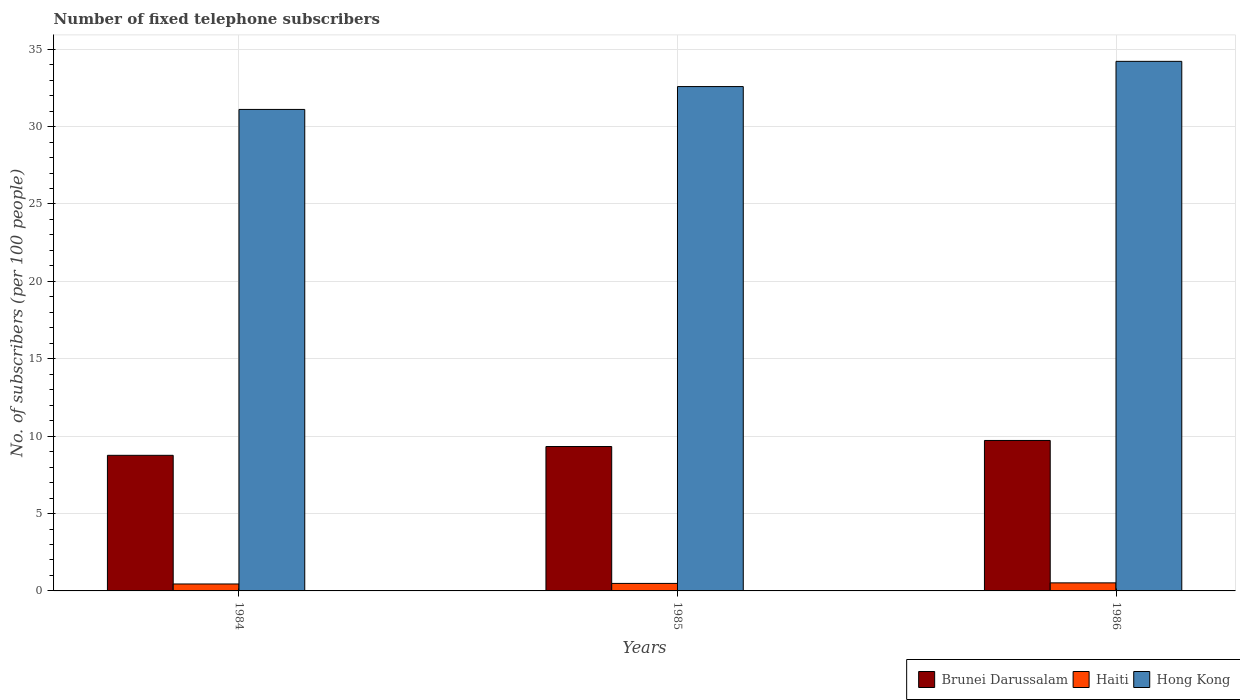How many different coloured bars are there?
Keep it short and to the point. 3. How many groups of bars are there?
Keep it short and to the point. 3. Are the number of bars per tick equal to the number of legend labels?
Provide a succinct answer. Yes. How many bars are there on the 1st tick from the left?
Offer a terse response. 3. How many bars are there on the 2nd tick from the right?
Your answer should be very brief. 3. What is the label of the 1st group of bars from the left?
Provide a short and direct response. 1984. In how many cases, is the number of bars for a given year not equal to the number of legend labels?
Give a very brief answer. 0. What is the number of fixed telephone subscribers in Haiti in 1986?
Provide a succinct answer. 0.52. Across all years, what is the maximum number of fixed telephone subscribers in Haiti?
Provide a short and direct response. 0.52. Across all years, what is the minimum number of fixed telephone subscribers in Haiti?
Your response must be concise. 0.45. What is the total number of fixed telephone subscribers in Brunei Darussalam in the graph?
Give a very brief answer. 27.81. What is the difference between the number of fixed telephone subscribers in Haiti in 1984 and that in 1985?
Ensure brevity in your answer.  -0.04. What is the difference between the number of fixed telephone subscribers in Haiti in 1986 and the number of fixed telephone subscribers in Brunei Darussalam in 1984?
Offer a terse response. -8.24. What is the average number of fixed telephone subscribers in Haiti per year?
Keep it short and to the point. 0.48. In the year 1986, what is the difference between the number of fixed telephone subscribers in Brunei Darussalam and number of fixed telephone subscribers in Hong Kong?
Give a very brief answer. -24.49. What is the ratio of the number of fixed telephone subscribers in Haiti in 1984 to that in 1986?
Provide a succinct answer. 0.86. Is the number of fixed telephone subscribers in Hong Kong in 1984 less than that in 1986?
Ensure brevity in your answer.  Yes. Is the difference between the number of fixed telephone subscribers in Brunei Darussalam in 1984 and 1986 greater than the difference between the number of fixed telephone subscribers in Hong Kong in 1984 and 1986?
Your response must be concise. Yes. What is the difference between the highest and the second highest number of fixed telephone subscribers in Brunei Darussalam?
Ensure brevity in your answer.  0.39. What is the difference between the highest and the lowest number of fixed telephone subscribers in Hong Kong?
Ensure brevity in your answer.  3.11. In how many years, is the number of fixed telephone subscribers in Brunei Darussalam greater than the average number of fixed telephone subscribers in Brunei Darussalam taken over all years?
Offer a very short reply. 2. What does the 3rd bar from the left in 1986 represents?
Make the answer very short. Hong Kong. What does the 2nd bar from the right in 1985 represents?
Your answer should be compact. Haiti. How many years are there in the graph?
Your answer should be compact. 3. What is the difference between two consecutive major ticks on the Y-axis?
Provide a short and direct response. 5. Are the values on the major ticks of Y-axis written in scientific E-notation?
Provide a short and direct response. No. Does the graph contain grids?
Provide a short and direct response. Yes. Where does the legend appear in the graph?
Offer a very short reply. Bottom right. How many legend labels are there?
Offer a terse response. 3. What is the title of the graph?
Your answer should be very brief. Number of fixed telephone subscribers. What is the label or title of the X-axis?
Provide a short and direct response. Years. What is the label or title of the Y-axis?
Provide a succinct answer. No. of subscribers (per 100 people). What is the No. of subscribers (per 100 people) in Brunei Darussalam in 1984?
Give a very brief answer. 8.76. What is the No. of subscribers (per 100 people) of Haiti in 1984?
Give a very brief answer. 0.45. What is the No. of subscribers (per 100 people) of Hong Kong in 1984?
Give a very brief answer. 31.11. What is the No. of subscribers (per 100 people) in Brunei Darussalam in 1985?
Your answer should be compact. 9.33. What is the No. of subscribers (per 100 people) in Haiti in 1985?
Provide a short and direct response. 0.49. What is the No. of subscribers (per 100 people) of Hong Kong in 1985?
Keep it short and to the point. 32.58. What is the No. of subscribers (per 100 people) of Brunei Darussalam in 1986?
Ensure brevity in your answer.  9.72. What is the No. of subscribers (per 100 people) of Haiti in 1986?
Provide a short and direct response. 0.52. What is the No. of subscribers (per 100 people) in Hong Kong in 1986?
Provide a short and direct response. 34.21. Across all years, what is the maximum No. of subscribers (per 100 people) in Brunei Darussalam?
Make the answer very short. 9.72. Across all years, what is the maximum No. of subscribers (per 100 people) of Haiti?
Give a very brief answer. 0.52. Across all years, what is the maximum No. of subscribers (per 100 people) in Hong Kong?
Offer a very short reply. 34.21. Across all years, what is the minimum No. of subscribers (per 100 people) in Brunei Darussalam?
Offer a terse response. 8.76. Across all years, what is the minimum No. of subscribers (per 100 people) of Haiti?
Ensure brevity in your answer.  0.45. Across all years, what is the minimum No. of subscribers (per 100 people) of Hong Kong?
Your answer should be compact. 31.11. What is the total No. of subscribers (per 100 people) in Brunei Darussalam in the graph?
Offer a very short reply. 27.81. What is the total No. of subscribers (per 100 people) of Haiti in the graph?
Provide a succinct answer. 1.45. What is the total No. of subscribers (per 100 people) of Hong Kong in the graph?
Your answer should be compact. 97.9. What is the difference between the No. of subscribers (per 100 people) of Brunei Darussalam in 1984 and that in 1985?
Provide a succinct answer. -0.57. What is the difference between the No. of subscribers (per 100 people) in Haiti in 1984 and that in 1985?
Your response must be concise. -0.04. What is the difference between the No. of subscribers (per 100 people) in Hong Kong in 1984 and that in 1985?
Your response must be concise. -1.48. What is the difference between the No. of subscribers (per 100 people) in Brunei Darussalam in 1984 and that in 1986?
Offer a very short reply. -0.96. What is the difference between the No. of subscribers (per 100 people) in Haiti in 1984 and that in 1986?
Your response must be concise. -0.07. What is the difference between the No. of subscribers (per 100 people) of Hong Kong in 1984 and that in 1986?
Offer a terse response. -3.11. What is the difference between the No. of subscribers (per 100 people) of Brunei Darussalam in 1985 and that in 1986?
Offer a very short reply. -0.39. What is the difference between the No. of subscribers (per 100 people) of Haiti in 1985 and that in 1986?
Provide a succinct answer. -0.04. What is the difference between the No. of subscribers (per 100 people) in Hong Kong in 1985 and that in 1986?
Your answer should be compact. -1.63. What is the difference between the No. of subscribers (per 100 people) of Brunei Darussalam in 1984 and the No. of subscribers (per 100 people) of Haiti in 1985?
Provide a succinct answer. 8.28. What is the difference between the No. of subscribers (per 100 people) of Brunei Darussalam in 1984 and the No. of subscribers (per 100 people) of Hong Kong in 1985?
Your answer should be very brief. -23.82. What is the difference between the No. of subscribers (per 100 people) in Haiti in 1984 and the No. of subscribers (per 100 people) in Hong Kong in 1985?
Your response must be concise. -32.14. What is the difference between the No. of subscribers (per 100 people) of Brunei Darussalam in 1984 and the No. of subscribers (per 100 people) of Haiti in 1986?
Offer a terse response. 8.24. What is the difference between the No. of subscribers (per 100 people) in Brunei Darussalam in 1984 and the No. of subscribers (per 100 people) in Hong Kong in 1986?
Your response must be concise. -25.45. What is the difference between the No. of subscribers (per 100 people) in Haiti in 1984 and the No. of subscribers (per 100 people) in Hong Kong in 1986?
Make the answer very short. -33.77. What is the difference between the No. of subscribers (per 100 people) of Brunei Darussalam in 1985 and the No. of subscribers (per 100 people) of Haiti in 1986?
Your answer should be very brief. 8.81. What is the difference between the No. of subscribers (per 100 people) of Brunei Darussalam in 1985 and the No. of subscribers (per 100 people) of Hong Kong in 1986?
Offer a very short reply. -24.88. What is the difference between the No. of subscribers (per 100 people) of Haiti in 1985 and the No. of subscribers (per 100 people) of Hong Kong in 1986?
Your answer should be very brief. -33.73. What is the average No. of subscribers (per 100 people) in Brunei Darussalam per year?
Provide a succinct answer. 9.27. What is the average No. of subscribers (per 100 people) in Haiti per year?
Keep it short and to the point. 0.48. What is the average No. of subscribers (per 100 people) in Hong Kong per year?
Offer a terse response. 32.63. In the year 1984, what is the difference between the No. of subscribers (per 100 people) of Brunei Darussalam and No. of subscribers (per 100 people) of Haiti?
Offer a terse response. 8.31. In the year 1984, what is the difference between the No. of subscribers (per 100 people) in Brunei Darussalam and No. of subscribers (per 100 people) in Hong Kong?
Offer a terse response. -22.35. In the year 1984, what is the difference between the No. of subscribers (per 100 people) of Haiti and No. of subscribers (per 100 people) of Hong Kong?
Your response must be concise. -30.66. In the year 1985, what is the difference between the No. of subscribers (per 100 people) of Brunei Darussalam and No. of subscribers (per 100 people) of Haiti?
Your response must be concise. 8.84. In the year 1985, what is the difference between the No. of subscribers (per 100 people) in Brunei Darussalam and No. of subscribers (per 100 people) in Hong Kong?
Give a very brief answer. -23.25. In the year 1985, what is the difference between the No. of subscribers (per 100 people) in Haiti and No. of subscribers (per 100 people) in Hong Kong?
Offer a very short reply. -32.1. In the year 1986, what is the difference between the No. of subscribers (per 100 people) in Brunei Darussalam and No. of subscribers (per 100 people) in Haiti?
Give a very brief answer. 9.2. In the year 1986, what is the difference between the No. of subscribers (per 100 people) in Brunei Darussalam and No. of subscribers (per 100 people) in Hong Kong?
Give a very brief answer. -24.49. In the year 1986, what is the difference between the No. of subscribers (per 100 people) of Haiti and No. of subscribers (per 100 people) of Hong Kong?
Make the answer very short. -33.69. What is the ratio of the No. of subscribers (per 100 people) of Brunei Darussalam in 1984 to that in 1985?
Your response must be concise. 0.94. What is the ratio of the No. of subscribers (per 100 people) in Haiti in 1984 to that in 1985?
Offer a very short reply. 0.92. What is the ratio of the No. of subscribers (per 100 people) in Hong Kong in 1984 to that in 1985?
Offer a very short reply. 0.95. What is the ratio of the No. of subscribers (per 100 people) in Brunei Darussalam in 1984 to that in 1986?
Provide a succinct answer. 0.9. What is the ratio of the No. of subscribers (per 100 people) of Haiti in 1984 to that in 1986?
Your answer should be compact. 0.86. What is the ratio of the No. of subscribers (per 100 people) of Hong Kong in 1984 to that in 1986?
Provide a succinct answer. 0.91. What is the ratio of the No. of subscribers (per 100 people) of Brunei Darussalam in 1985 to that in 1986?
Provide a succinct answer. 0.96. What is the ratio of the No. of subscribers (per 100 people) of Haiti in 1985 to that in 1986?
Your answer should be very brief. 0.93. What is the difference between the highest and the second highest No. of subscribers (per 100 people) in Brunei Darussalam?
Give a very brief answer. 0.39. What is the difference between the highest and the second highest No. of subscribers (per 100 people) of Haiti?
Offer a very short reply. 0.04. What is the difference between the highest and the second highest No. of subscribers (per 100 people) in Hong Kong?
Provide a succinct answer. 1.63. What is the difference between the highest and the lowest No. of subscribers (per 100 people) in Brunei Darussalam?
Provide a succinct answer. 0.96. What is the difference between the highest and the lowest No. of subscribers (per 100 people) of Haiti?
Your answer should be very brief. 0.07. What is the difference between the highest and the lowest No. of subscribers (per 100 people) of Hong Kong?
Make the answer very short. 3.11. 